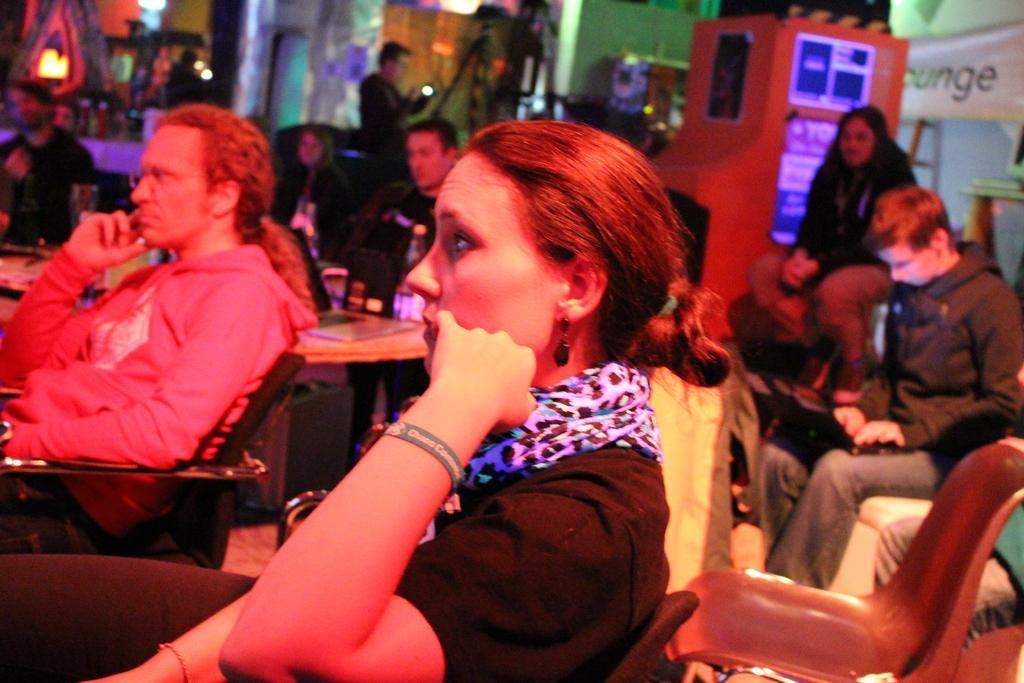Could you give a brief overview of what you see in this image? Here I can see few people sitting on the chairs facing towards the left side. On the right side there is a wall to which a banner is attached. In the background there are many objects and lights and also I can see a wall. On the left side there is a table on which some objects are placed. 